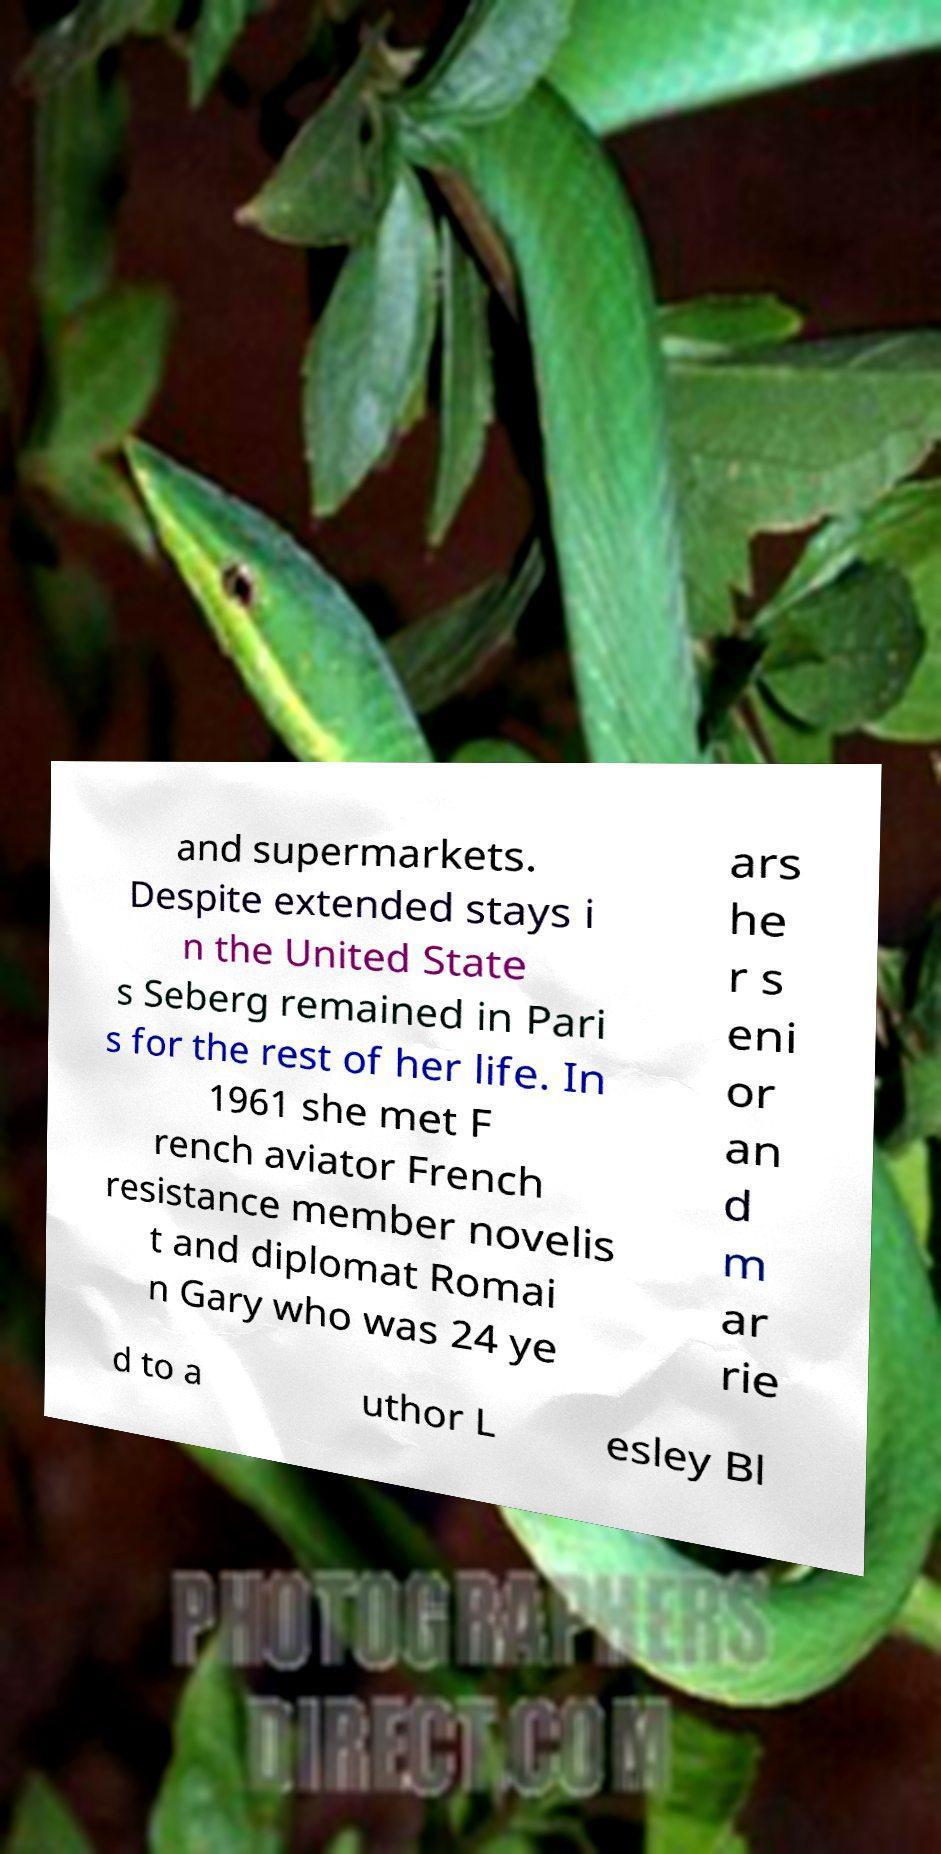Please identify and transcribe the text found in this image. and supermarkets. Despite extended stays i n the United State s Seberg remained in Pari s for the rest of her life. In 1961 she met F rench aviator French resistance member novelis t and diplomat Romai n Gary who was 24 ye ars he r s eni or an d m ar rie d to a uthor L esley Bl 